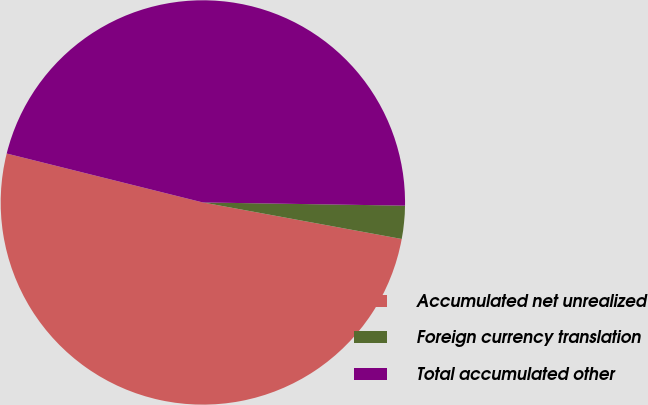<chart> <loc_0><loc_0><loc_500><loc_500><pie_chart><fcel>Accumulated net unrealized<fcel>Foreign currency translation<fcel>Total accumulated other<nl><fcel>51.0%<fcel>2.64%<fcel>46.36%<nl></chart> 